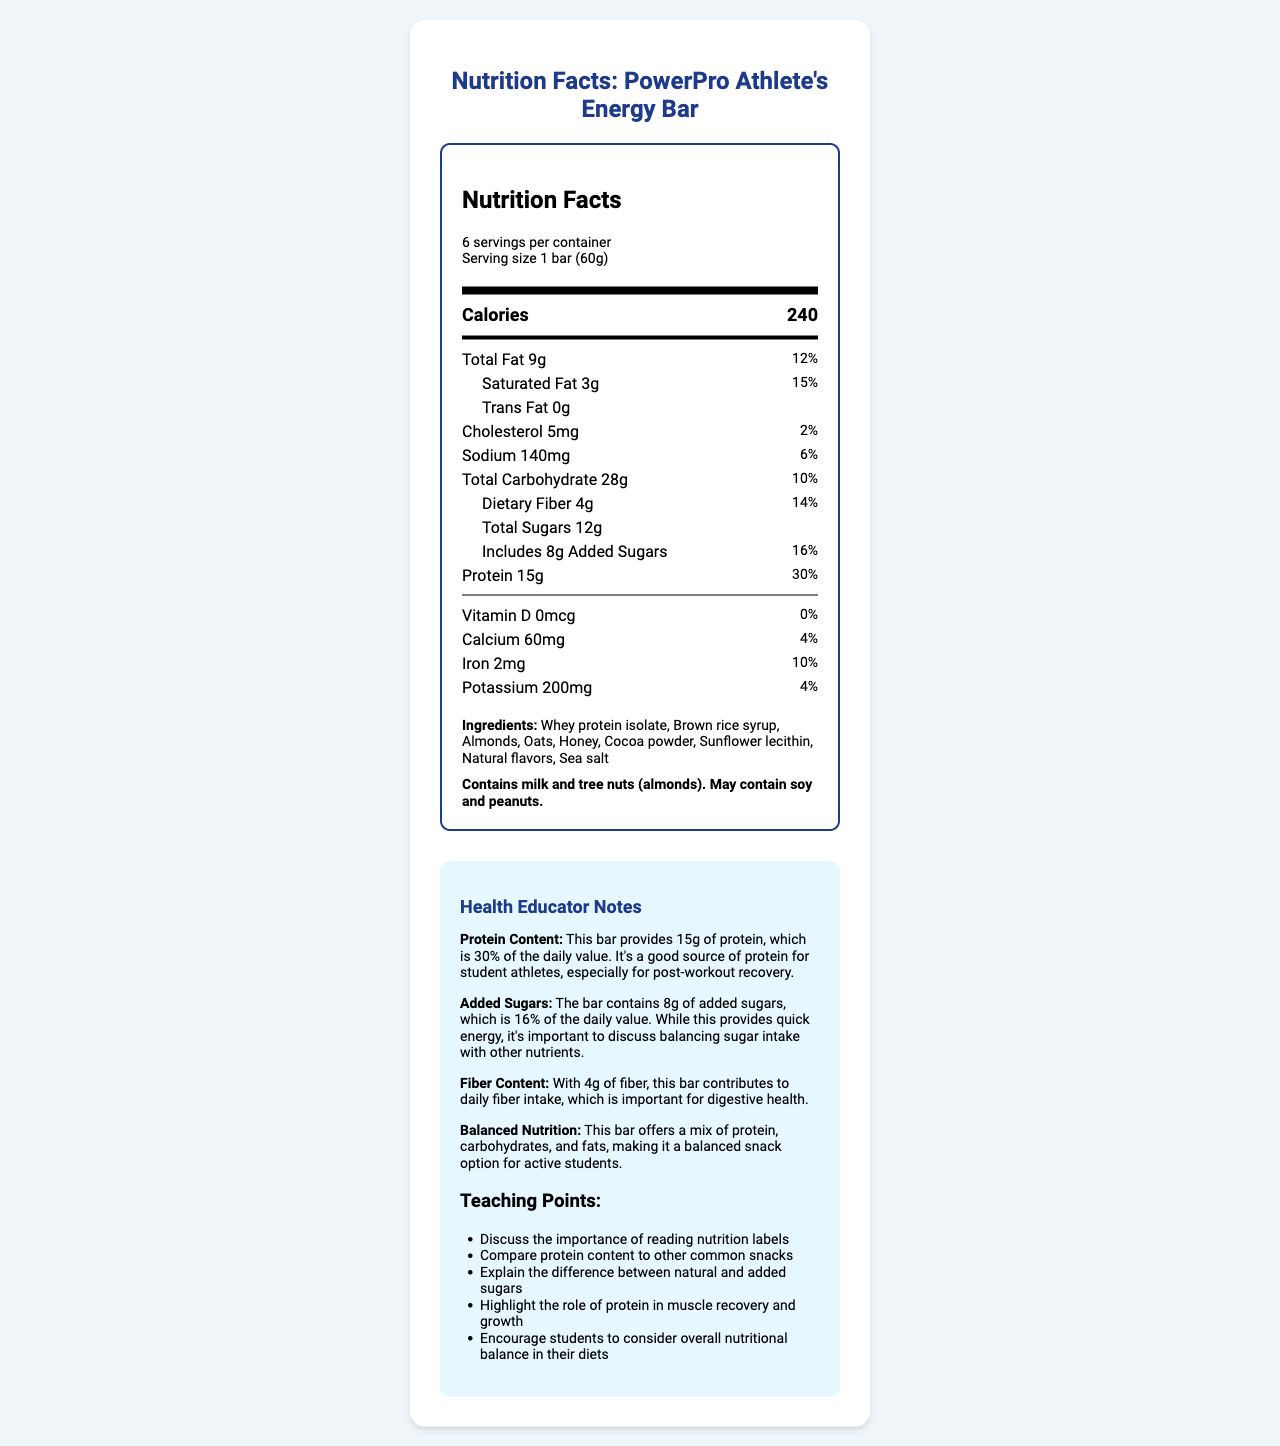what is the protein content per serving in the PowerPro Athlete's Energy Bar? The document states that the protein content per serving size of 1 bar (60g) is 15g.
Answer: 15g how many grams of total sugars are in each serving of the bar? According to the document, each serving contains 12g of total sugars.
Answer: 12g what percentage of the daily value for added sugars does one bar provide? The nutrition facts label indicates that 8g of added sugars is 16% of the daily value.
Answer: 16% how many servings are in one container of PowerPro Athlete's Energy Bar? The document specifies that there are 6 servings per container.
Answer: 6 list three main ingredients of the PowerPro Athlete's Energy Bar. These ingredients are listed first in the ingredients section, suggesting they are predominant.
Answer: Whey protein isolate, Brown rice syrup, Almonds how much dietary fiber is in each serving? The nutrition facts list the dietary fiber content as 4g per serving.
Answer: 4g which nutrient is not present in the PowerPro Athlete's Energy Bar? A. Vitamin D B. Calcium C. Iron D. Potassium The document shows that Vitamin D is listed as 0mcg, which means it is not present in the bar.
Answer: A. Vitamin D what percentage of the daily value for calcium does one bar provide? A. 2% B. 4% C. 6% D. 10% The nutrition facts list the daily value for calcium as 4%.
Answer: B. 4% are there any allergens in the PowerPro Athlete's Energy Bar? The allergen information section indicates that the bar contains milk and tree nuts (almonds).
Answer: Yes what is the primary role of protein in an athlete's diet? According to the educator’s notes, protein is essential for muscle recovery and growth, which is important for student athletes.
Answer: Muscle recovery and growth can students use this bar as a balanced snack option? The educator's notes mention that the bar offers a mix of protein, carbohydrates, and fats, making it a balanced snack.
Answer: Yes what is highlighted in the teaching points related to reading labels? The teaching points include a note about discussing the importance of reading nutrition labels.
Answer: Importance of reading nutrition labels what is the main idea of the document? The document includes detailed nutrition facts, ingredients, allergen information, and educator notes focusing on protein content, added sugars, and the bar as a balanced snack option.
Answer: It provides nutritional information about the PowerPro Athlete's Energy Bar, emphasizing its content of protein and added sugars, balanced nutrition, and its benefits for student athletes. how much time is recommended for athletes to consume the bar before a workout? The document does not provide any information about the recommended time for consuming the bar before a workout.
Answer: Not enough information 